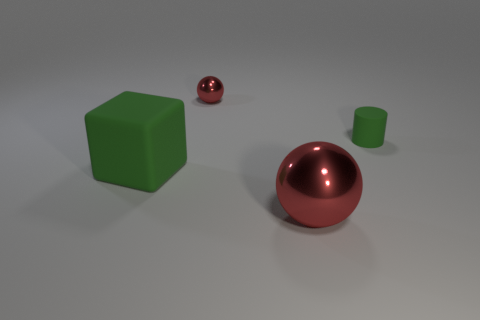Add 3 tiny green rubber cubes. How many objects exist? 7 Add 2 big green matte blocks. How many big green matte blocks are left? 3 Add 3 shiny spheres. How many shiny spheres exist? 5 Subtract 0 gray balls. How many objects are left? 4 Subtract all red objects. Subtract all green things. How many objects are left? 0 